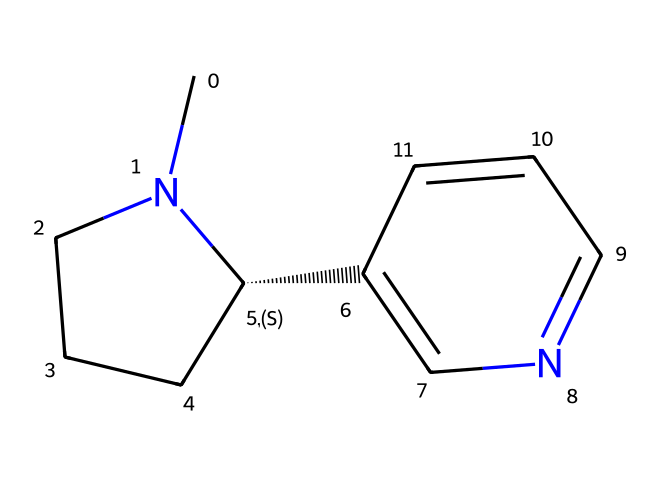What is the molecular formula of nicotine? To determine the molecular formula, we count the number of each type of atom in the SMILES representation. The structure includes two carbon rings and a nitrogen atom, leading to a total of 10 carbon (C), 14 hydrogen (H), and 2 nitrogen (N) atoms. Therefore, the molecular formula is C10H14N2.
Answer: C10H14N2 How many rings are present in the nicotine structure? Analyzing the SMILES representation, we can identify that there are two distinct rings in the structure. The "N1" and "C1" indicate the starting point of the first ring, while "C2=CN" indicates the presence of a second ring.
Answer: 2 Which atoms are responsible for the basicity of nicotine? The basicity of nicotine stems from the nitrogen atoms (N) in its structure, which can accept protons due to their lone pair of electrons. The two nitrogen atoms in the chemical structure make it a basic compound.
Answer: nitrogen What type of compound is nicotine classified as? Nicotine, based on its molecular structure featuring nitrogen within a cyclic arrangement, is classified as an alkaloid. Alkaloids are a group of naturally occurring organic compounds that mostly contain basic nitrogen atoms.
Answer: alkaloid How many carbon atoms are in the nicotine molecule? By closely inspecting the structure derived from the SMILES representation, we count the carbon atoms (C) one by one. There are a total of 10 carbon atoms present in the nicotine structure.
Answer: 10 What is the stereochemistry of the nicotine molecule? The stereochemistry can be determined by observing the chiral center indicated by "[C@H]". Here, the "@" symbol denotes a specific configuration for this carbon atom, signifying that nicotine has a chiral center and thus exhibits stereoisomerism.
Answer: chiral 